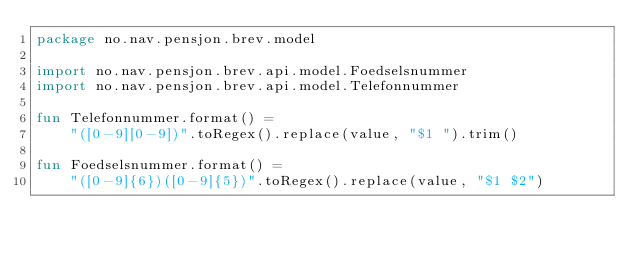Convert code to text. <code><loc_0><loc_0><loc_500><loc_500><_Kotlin_>package no.nav.pensjon.brev.model

import no.nav.pensjon.brev.api.model.Foedselsnummer
import no.nav.pensjon.brev.api.model.Telefonnummer

fun Telefonnummer.format() =
    "([0-9][0-9])".toRegex().replace(value, "$1 ").trim()

fun Foedselsnummer.format() =
    "([0-9]{6})([0-9]{5})".toRegex().replace(value, "$1 $2")</code> 